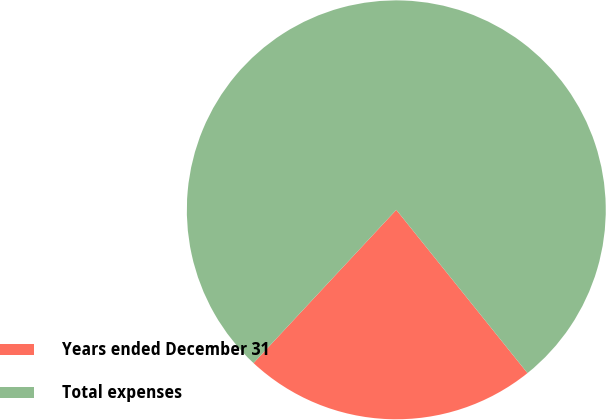Convert chart to OTSL. <chart><loc_0><loc_0><loc_500><loc_500><pie_chart><fcel>Years ended December 31<fcel>Total expenses<nl><fcel>22.71%<fcel>77.29%<nl></chart> 